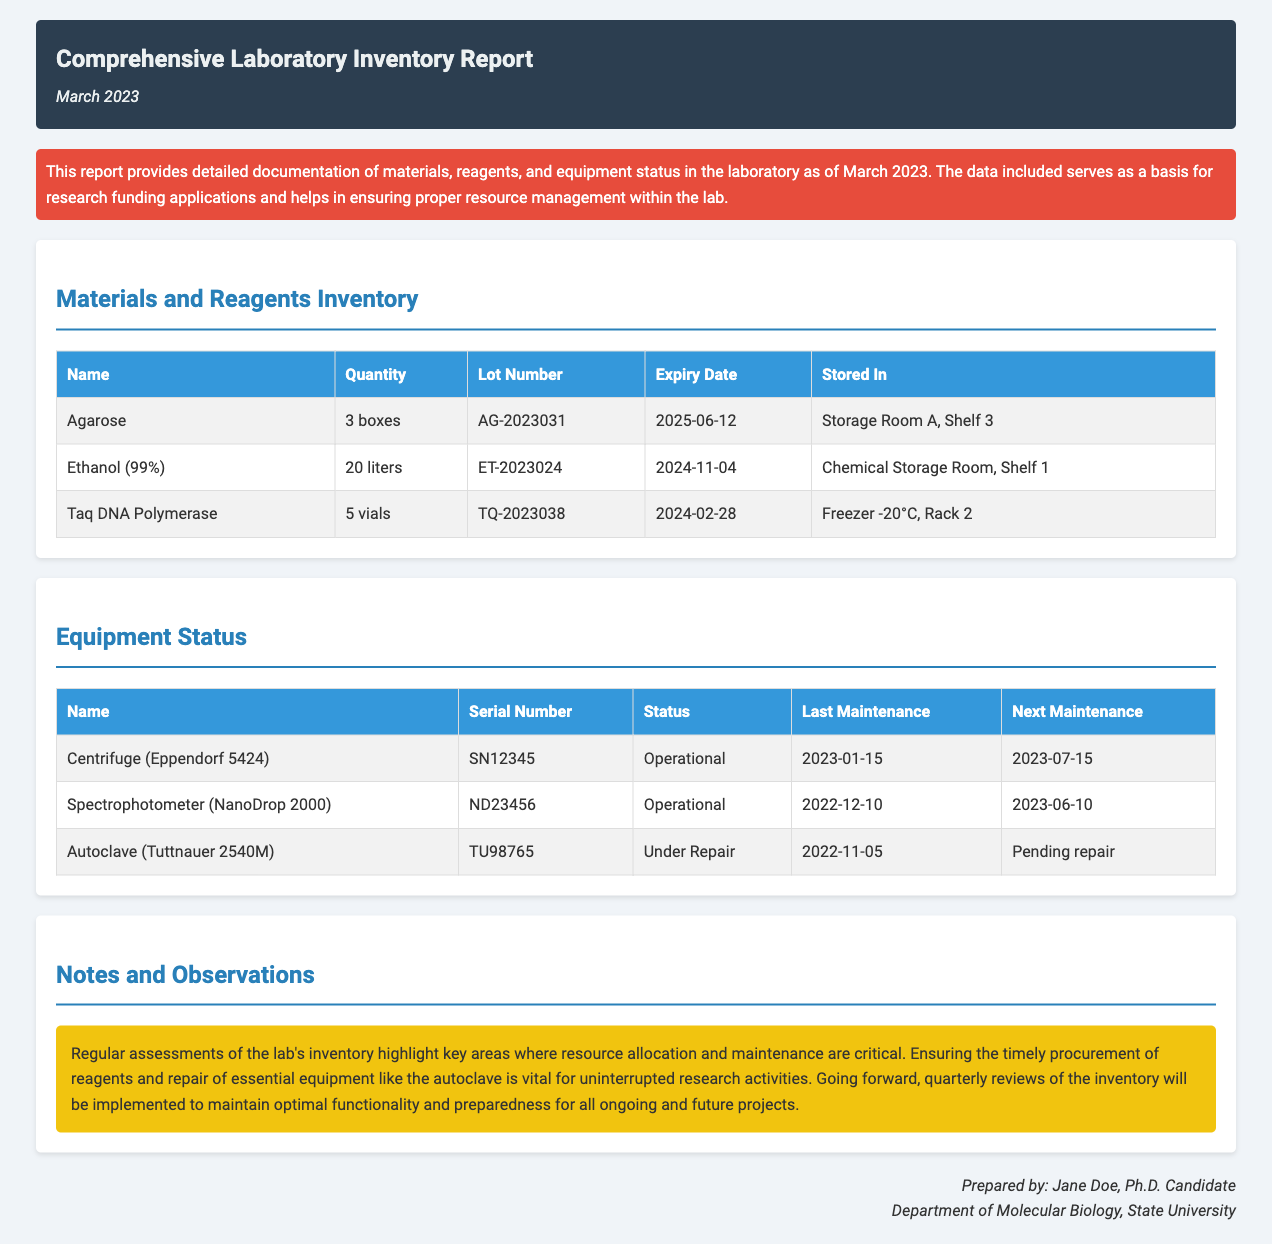what is the date of the report? The report date is explicitly mentioned in the header section of the document.
Answer: March 2023 how many boxes of Agarose are available? The inventory table lists the quantity of Agarose in the relevant section.
Answer: 3 boxes what is the expiry date of Ethanol (99%)? The expiry date is provided in the inventory details for Ethanol (99%).
Answer: 2024-11-04 what is the status of the Autoclave? The equipment status table indicates the condition of the Autoclave.
Answer: Under Repair when was the last maintenance of the Centrifuge? The last maintenance date is provided in the equipment status section.
Answer: 2023-01-15 who prepared the report? The document footer states who prepared the comprehensive inventory report.
Answer: Jane Doe how many vials of Taq DNA Polymerase are in stock? The number of Taq DNA Polymerase vials is mentioned in the materials inventory.
Answer: 5 vials what is the next maintenance date for the Spectrophotometer? The next maintenance date is listed in the equipment status table for the Spectrophotometer.
Answer: 2023-06-10 what is stated regarding the potential need for regular assessments? The notes section outlines the importance of regular assessments for resource management.
Answer: Quarterly reviews of the inventory will be implemented 